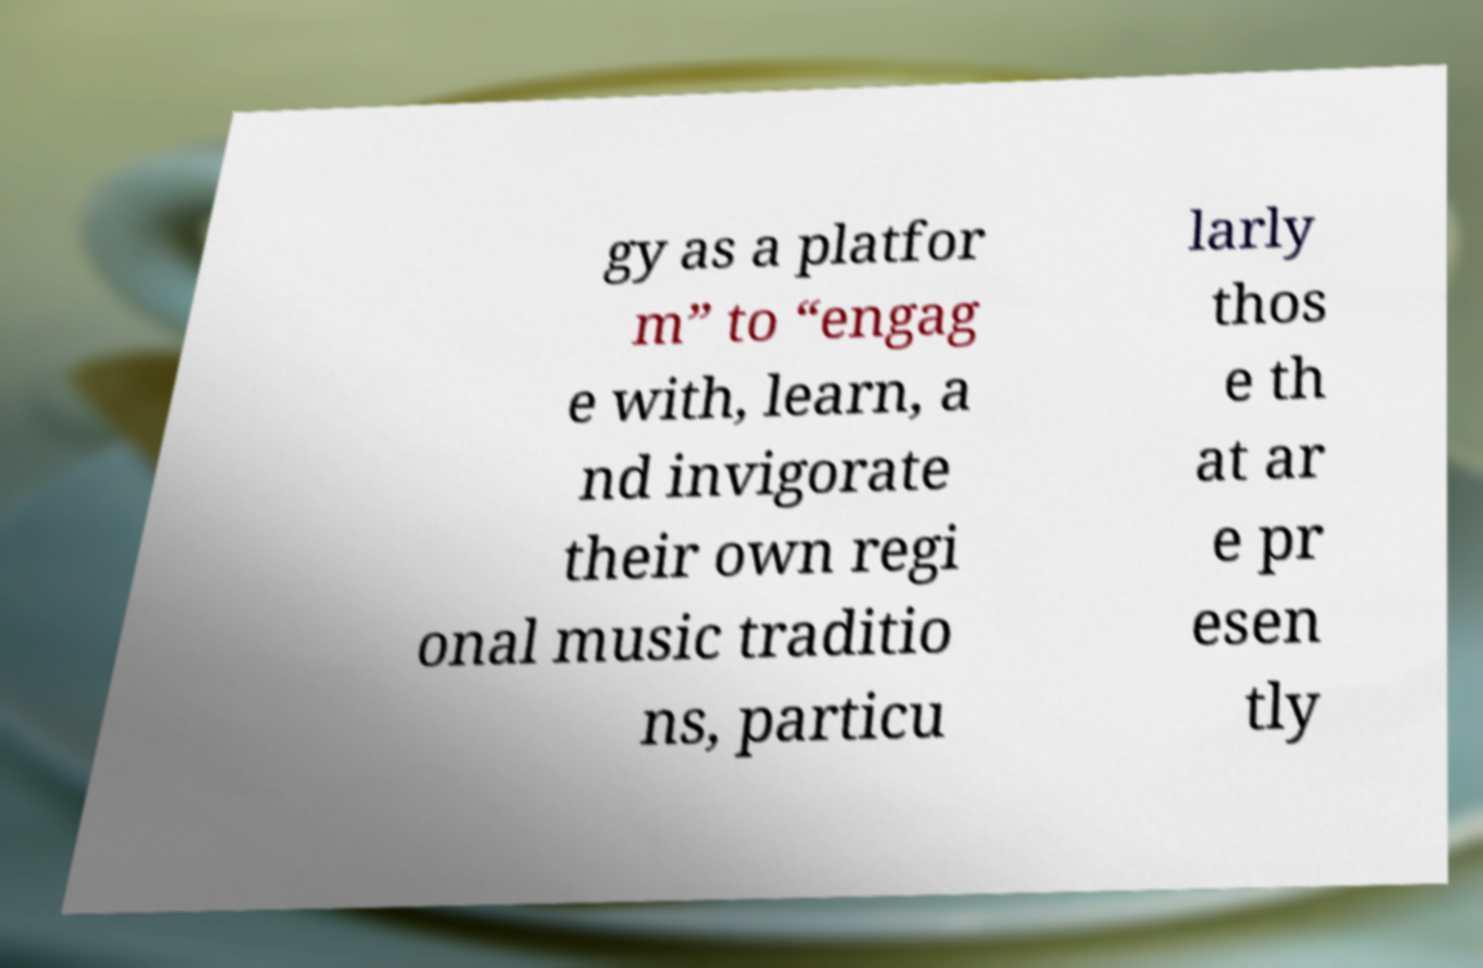There's text embedded in this image that I need extracted. Can you transcribe it verbatim? gy as a platfor m” to “engag e with, learn, a nd invigorate their own regi onal music traditio ns, particu larly thos e th at ar e pr esen tly 